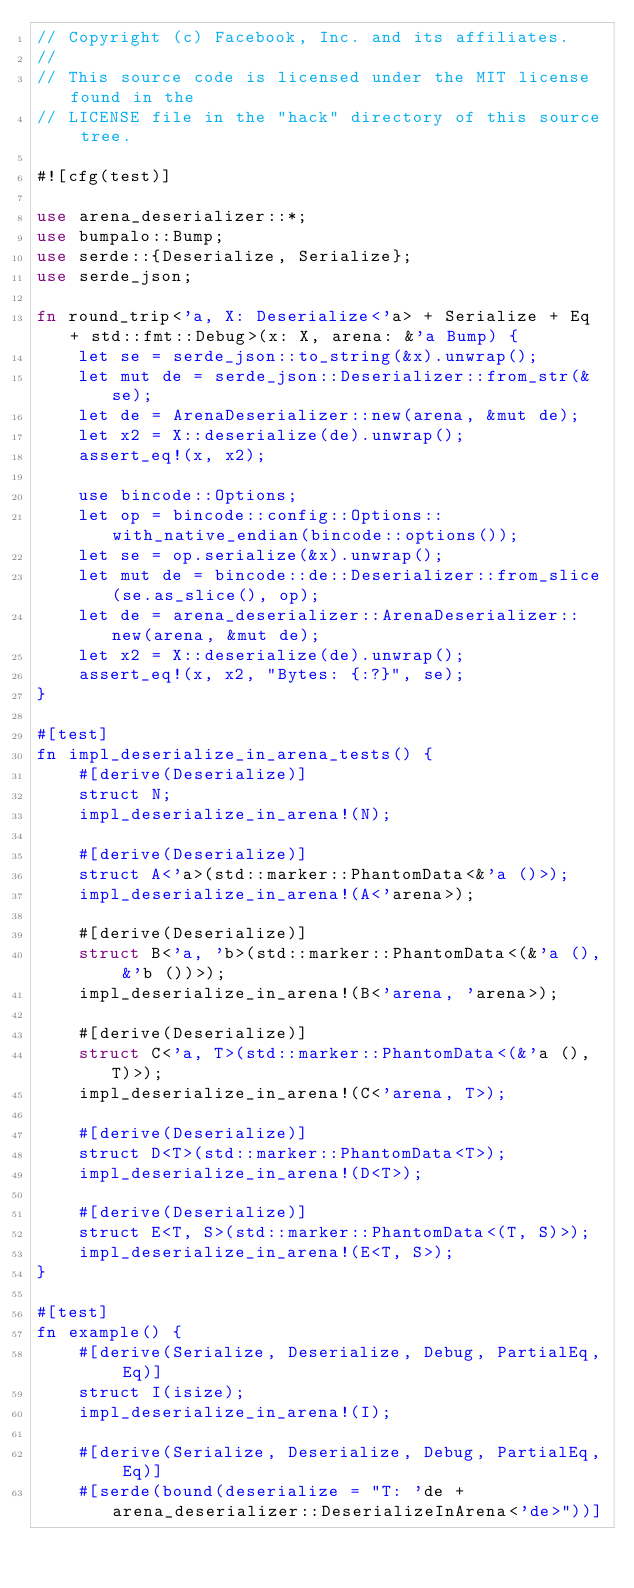Convert code to text. <code><loc_0><loc_0><loc_500><loc_500><_Rust_>// Copyright (c) Facebook, Inc. and its affiliates.
//
// This source code is licensed under the MIT license found in the
// LICENSE file in the "hack" directory of this source tree.

#![cfg(test)]

use arena_deserializer::*;
use bumpalo::Bump;
use serde::{Deserialize, Serialize};
use serde_json;

fn round_trip<'a, X: Deserialize<'a> + Serialize + Eq + std::fmt::Debug>(x: X, arena: &'a Bump) {
    let se = serde_json::to_string(&x).unwrap();
    let mut de = serde_json::Deserializer::from_str(&se);
    let de = ArenaDeserializer::new(arena, &mut de);
    let x2 = X::deserialize(de).unwrap();
    assert_eq!(x, x2);

    use bincode::Options;
    let op = bincode::config::Options::with_native_endian(bincode::options());
    let se = op.serialize(&x).unwrap();
    let mut de = bincode::de::Deserializer::from_slice(se.as_slice(), op);
    let de = arena_deserializer::ArenaDeserializer::new(arena, &mut de);
    let x2 = X::deserialize(de).unwrap();
    assert_eq!(x, x2, "Bytes: {:?}", se);
}

#[test]
fn impl_deserialize_in_arena_tests() {
    #[derive(Deserialize)]
    struct N;
    impl_deserialize_in_arena!(N);

    #[derive(Deserialize)]
    struct A<'a>(std::marker::PhantomData<&'a ()>);
    impl_deserialize_in_arena!(A<'arena>);

    #[derive(Deserialize)]
    struct B<'a, 'b>(std::marker::PhantomData<(&'a (), &'b ())>);
    impl_deserialize_in_arena!(B<'arena, 'arena>);

    #[derive(Deserialize)]
    struct C<'a, T>(std::marker::PhantomData<(&'a (), T)>);
    impl_deserialize_in_arena!(C<'arena, T>);

    #[derive(Deserialize)]
    struct D<T>(std::marker::PhantomData<T>);
    impl_deserialize_in_arena!(D<T>);

    #[derive(Deserialize)]
    struct E<T, S>(std::marker::PhantomData<(T, S)>);
    impl_deserialize_in_arena!(E<T, S>);
}

#[test]
fn example() {
    #[derive(Serialize, Deserialize, Debug, PartialEq, Eq)]
    struct I(isize);
    impl_deserialize_in_arena!(I);

    #[derive(Serialize, Deserialize, Debug, PartialEq, Eq)]
    #[serde(bound(deserialize = "T: 'de + arena_deserializer::DeserializeInArena<'de>"))]</code> 